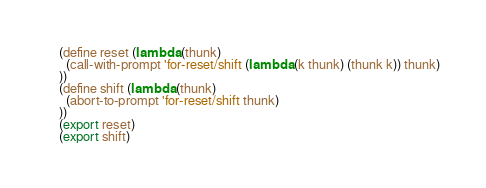<code> <loc_0><loc_0><loc_500><loc_500><_Lisp_>(define reset (lambda (thunk)
  (call-with-prompt 'for-reset/shift (lambda (k thunk) (thunk k)) thunk)
))
(define shift (lambda (thunk)
  (abort-to-prompt 'for-reset/shift thunk)
))
(export reset)
(export shift)
</code> 